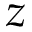Convert formula to latex. <formula><loc_0><loc_0><loc_500><loc_500>z</formula> 